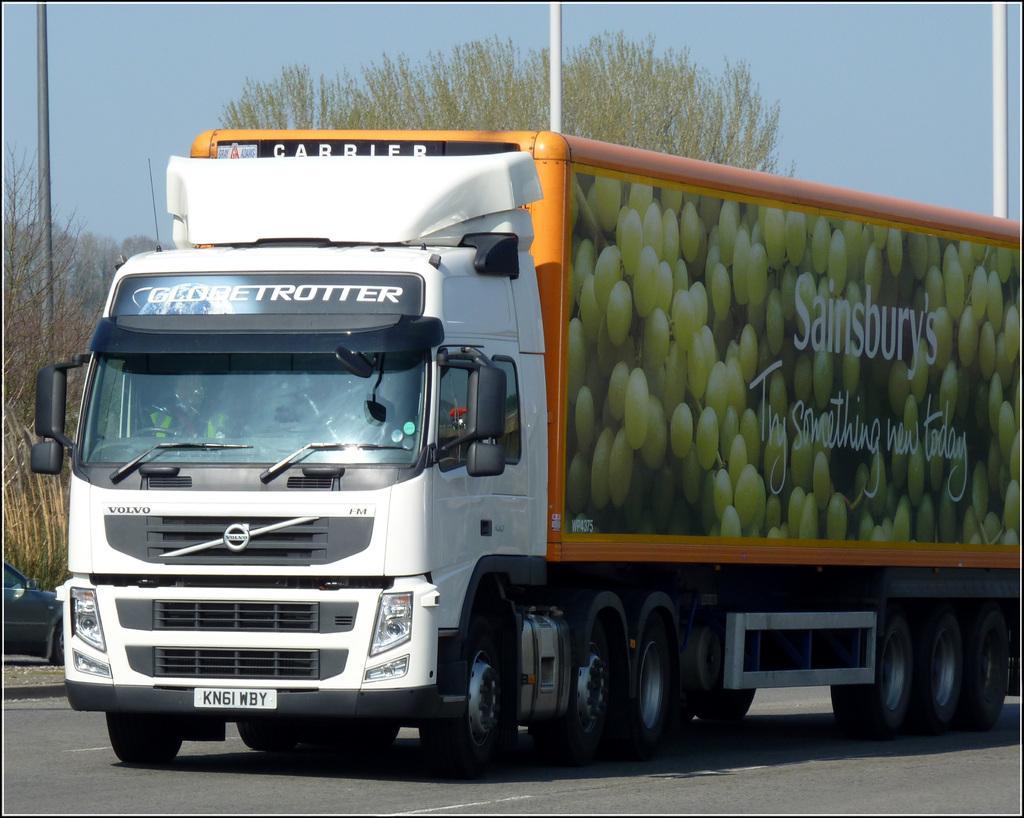Can you describe this image briefly? In the center of the image there is a truck on the road. In the background of the image there are trees,poles and sky. 